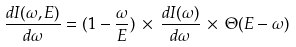<formula> <loc_0><loc_0><loc_500><loc_500>\frac { d I ( \omega , E ) } { d \omega } = ( 1 - \frac { \omega } { E } ) \, \times \, \frac { d I ( \omega ) } { d \omega } \, \times \, \Theta ( E - \omega )</formula> 